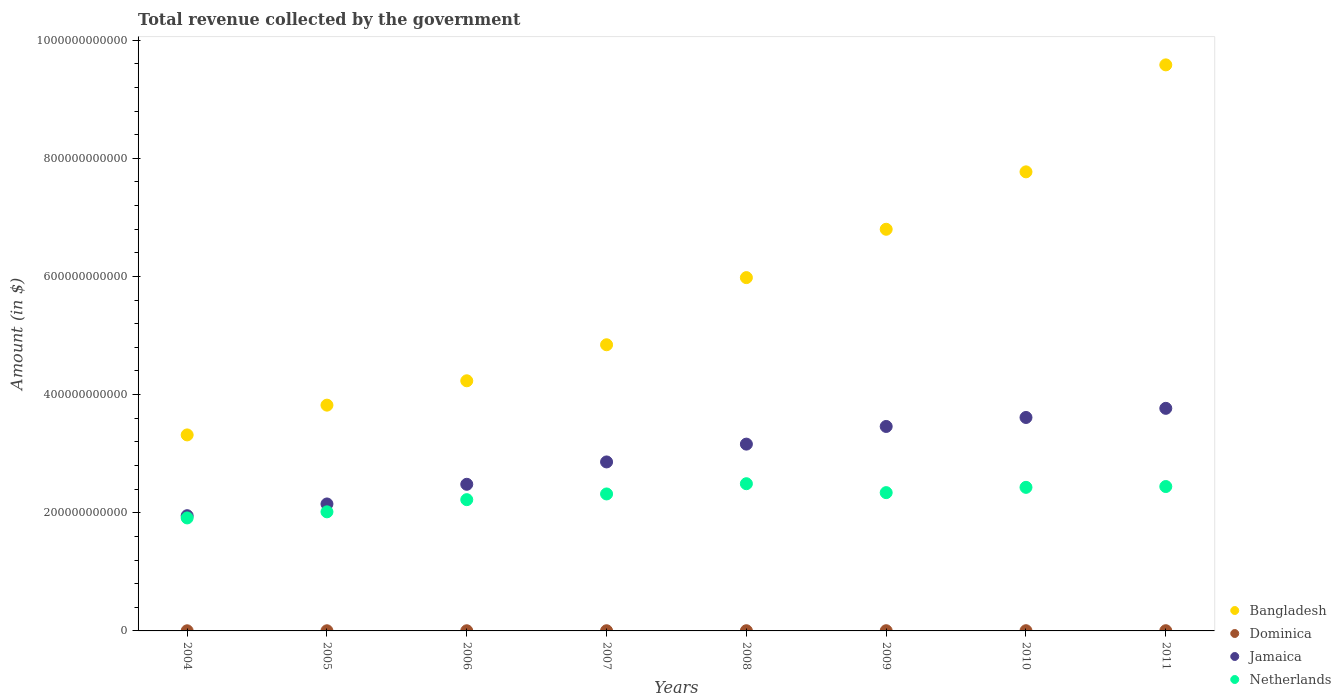How many different coloured dotlines are there?
Ensure brevity in your answer.  4. Is the number of dotlines equal to the number of legend labels?
Your response must be concise. Yes. What is the total revenue collected by the government in Netherlands in 2005?
Provide a succinct answer. 2.02e+11. Across all years, what is the maximum total revenue collected by the government in Bangladesh?
Provide a succinct answer. 9.58e+11. Across all years, what is the minimum total revenue collected by the government in Bangladesh?
Give a very brief answer. 3.32e+11. In which year was the total revenue collected by the government in Dominica maximum?
Make the answer very short. 2011. In which year was the total revenue collected by the government in Netherlands minimum?
Your answer should be very brief. 2004. What is the total total revenue collected by the government in Bangladesh in the graph?
Provide a short and direct response. 4.64e+12. What is the difference between the total revenue collected by the government in Netherlands in 2006 and that in 2008?
Provide a succinct answer. -2.70e+1. What is the difference between the total revenue collected by the government in Dominica in 2006 and the total revenue collected by the government in Netherlands in 2011?
Provide a succinct answer. -2.44e+11. What is the average total revenue collected by the government in Bangladesh per year?
Make the answer very short. 5.79e+11. In the year 2006, what is the difference between the total revenue collected by the government in Bangladesh and total revenue collected by the government in Jamaica?
Give a very brief answer. 1.75e+11. In how many years, is the total revenue collected by the government in Dominica greater than 520000000000 $?
Offer a very short reply. 0. What is the ratio of the total revenue collected by the government in Bangladesh in 2004 to that in 2010?
Your response must be concise. 0.43. What is the difference between the highest and the second highest total revenue collected by the government in Jamaica?
Make the answer very short. 1.55e+1. What is the difference between the highest and the lowest total revenue collected by the government in Netherlands?
Ensure brevity in your answer.  5.79e+1. Is the sum of the total revenue collected by the government in Jamaica in 2007 and 2008 greater than the maximum total revenue collected by the government in Netherlands across all years?
Provide a succinct answer. Yes. Is it the case that in every year, the sum of the total revenue collected by the government in Bangladesh and total revenue collected by the government in Dominica  is greater than the sum of total revenue collected by the government in Jamaica and total revenue collected by the government in Netherlands?
Give a very brief answer. No. Is the total revenue collected by the government in Dominica strictly greater than the total revenue collected by the government in Netherlands over the years?
Your answer should be compact. No. What is the difference between two consecutive major ticks on the Y-axis?
Provide a succinct answer. 2.00e+11. Does the graph contain grids?
Your response must be concise. No. How are the legend labels stacked?
Offer a very short reply. Vertical. What is the title of the graph?
Your answer should be compact. Total revenue collected by the government. Does "Ecuador" appear as one of the legend labels in the graph?
Offer a very short reply. No. What is the label or title of the X-axis?
Keep it short and to the point. Years. What is the label or title of the Y-axis?
Give a very brief answer. Amount (in $). What is the Amount (in $) of Bangladesh in 2004?
Make the answer very short. 3.32e+11. What is the Amount (in $) of Dominica in 2004?
Your response must be concise. 2.34e+08. What is the Amount (in $) in Jamaica in 2004?
Your response must be concise. 1.95e+11. What is the Amount (in $) of Netherlands in 2004?
Keep it short and to the point. 1.91e+11. What is the Amount (in $) of Bangladesh in 2005?
Offer a very short reply. 3.82e+11. What is the Amount (in $) in Dominica in 2005?
Offer a terse response. 2.55e+08. What is the Amount (in $) of Jamaica in 2005?
Ensure brevity in your answer.  2.15e+11. What is the Amount (in $) of Netherlands in 2005?
Provide a short and direct response. 2.02e+11. What is the Amount (in $) in Bangladesh in 2006?
Provide a succinct answer. 4.23e+11. What is the Amount (in $) in Dominica in 2006?
Your answer should be very brief. 2.69e+08. What is the Amount (in $) in Jamaica in 2006?
Provide a short and direct response. 2.48e+11. What is the Amount (in $) of Netherlands in 2006?
Provide a short and direct response. 2.22e+11. What is the Amount (in $) of Bangladesh in 2007?
Give a very brief answer. 4.84e+11. What is the Amount (in $) in Dominica in 2007?
Your answer should be compact. 3.12e+08. What is the Amount (in $) in Jamaica in 2007?
Ensure brevity in your answer.  2.86e+11. What is the Amount (in $) in Netherlands in 2007?
Your answer should be very brief. 2.32e+11. What is the Amount (in $) of Bangladesh in 2008?
Offer a terse response. 5.98e+11. What is the Amount (in $) of Dominica in 2008?
Provide a succinct answer. 3.38e+08. What is the Amount (in $) of Jamaica in 2008?
Keep it short and to the point. 3.16e+11. What is the Amount (in $) of Netherlands in 2008?
Your answer should be compact. 2.49e+11. What is the Amount (in $) in Bangladesh in 2009?
Your response must be concise. 6.80e+11. What is the Amount (in $) of Dominica in 2009?
Provide a succinct answer. 3.50e+08. What is the Amount (in $) in Jamaica in 2009?
Provide a short and direct response. 3.46e+11. What is the Amount (in $) of Netherlands in 2009?
Offer a very short reply. 2.34e+11. What is the Amount (in $) in Bangladesh in 2010?
Offer a very short reply. 7.77e+11. What is the Amount (in $) in Dominica in 2010?
Provide a succinct answer. 3.52e+08. What is the Amount (in $) of Jamaica in 2010?
Your answer should be very brief. 3.61e+11. What is the Amount (in $) in Netherlands in 2010?
Provide a short and direct response. 2.43e+11. What is the Amount (in $) in Bangladesh in 2011?
Your answer should be compact. 9.58e+11. What is the Amount (in $) in Dominica in 2011?
Offer a terse response. 3.57e+08. What is the Amount (in $) in Jamaica in 2011?
Your response must be concise. 3.77e+11. What is the Amount (in $) in Netherlands in 2011?
Provide a succinct answer. 2.44e+11. Across all years, what is the maximum Amount (in $) in Bangladesh?
Provide a succinct answer. 9.58e+11. Across all years, what is the maximum Amount (in $) in Dominica?
Your response must be concise. 3.57e+08. Across all years, what is the maximum Amount (in $) in Jamaica?
Your answer should be compact. 3.77e+11. Across all years, what is the maximum Amount (in $) in Netherlands?
Give a very brief answer. 2.49e+11. Across all years, what is the minimum Amount (in $) in Bangladesh?
Provide a short and direct response. 3.32e+11. Across all years, what is the minimum Amount (in $) of Dominica?
Offer a very short reply. 2.34e+08. Across all years, what is the minimum Amount (in $) of Jamaica?
Offer a very short reply. 1.95e+11. Across all years, what is the minimum Amount (in $) of Netherlands?
Offer a very short reply. 1.91e+11. What is the total Amount (in $) in Bangladesh in the graph?
Your answer should be compact. 4.64e+12. What is the total Amount (in $) in Dominica in the graph?
Your response must be concise. 2.47e+09. What is the total Amount (in $) of Jamaica in the graph?
Your answer should be compact. 2.34e+12. What is the total Amount (in $) of Netherlands in the graph?
Make the answer very short. 1.82e+12. What is the difference between the Amount (in $) of Bangladesh in 2004 and that in 2005?
Make the answer very short. -5.04e+1. What is the difference between the Amount (in $) of Dominica in 2004 and that in 2005?
Your answer should be very brief. -2.06e+07. What is the difference between the Amount (in $) of Jamaica in 2004 and that in 2005?
Make the answer very short. -1.99e+1. What is the difference between the Amount (in $) in Netherlands in 2004 and that in 2005?
Your answer should be compact. -1.03e+1. What is the difference between the Amount (in $) in Bangladesh in 2004 and that in 2006?
Your answer should be compact. -9.16e+1. What is the difference between the Amount (in $) in Dominica in 2004 and that in 2006?
Provide a short and direct response. -3.46e+07. What is the difference between the Amount (in $) in Jamaica in 2004 and that in 2006?
Your response must be concise. -5.32e+1. What is the difference between the Amount (in $) of Netherlands in 2004 and that in 2006?
Give a very brief answer. -3.09e+1. What is the difference between the Amount (in $) of Bangladesh in 2004 and that in 2007?
Keep it short and to the point. -1.53e+11. What is the difference between the Amount (in $) of Dominica in 2004 and that in 2007?
Give a very brief answer. -7.77e+07. What is the difference between the Amount (in $) in Jamaica in 2004 and that in 2007?
Give a very brief answer. -9.10e+1. What is the difference between the Amount (in $) in Netherlands in 2004 and that in 2007?
Your response must be concise. -4.06e+1. What is the difference between the Amount (in $) in Bangladesh in 2004 and that in 2008?
Offer a terse response. -2.66e+11. What is the difference between the Amount (in $) of Dominica in 2004 and that in 2008?
Your answer should be very brief. -1.03e+08. What is the difference between the Amount (in $) of Jamaica in 2004 and that in 2008?
Make the answer very short. -1.21e+11. What is the difference between the Amount (in $) in Netherlands in 2004 and that in 2008?
Make the answer very short. -5.79e+1. What is the difference between the Amount (in $) in Bangladesh in 2004 and that in 2009?
Your answer should be compact. -3.48e+11. What is the difference between the Amount (in $) in Dominica in 2004 and that in 2009?
Offer a terse response. -1.16e+08. What is the difference between the Amount (in $) of Jamaica in 2004 and that in 2009?
Provide a succinct answer. -1.51e+11. What is the difference between the Amount (in $) in Netherlands in 2004 and that in 2009?
Make the answer very short. -4.28e+1. What is the difference between the Amount (in $) in Bangladesh in 2004 and that in 2010?
Make the answer very short. -4.45e+11. What is the difference between the Amount (in $) of Dominica in 2004 and that in 2010?
Ensure brevity in your answer.  -1.17e+08. What is the difference between the Amount (in $) of Jamaica in 2004 and that in 2010?
Make the answer very short. -1.66e+11. What is the difference between the Amount (in $) in Netherlands in 2004 and that in 2010?
Provide a short and direct response. -5.18e+1. What is the difference between the Amount (in $) of Bangladesh in 2004 and that in 2011?
Provide a short and direct response. -6.26e+11. What is the difference between the Amount (in $) of Dominica in 2004 and that in 2011?
Offer a terse response. -1.23e+08. What is the difference between the Amount (in $) of Jamaica in 2004 and that in 2011?
Provide a succinct answer. -1.82e+11. What is the difference between the Amount (in $) of Netherlands in 2004 and that in 2011?
Provide a short and direct response. -5.31e+1. What is the difference between the Amount (in $) of Bangladesh in 2005 and that in 2006?
Keep it short and to the point. -4.12e+1. What is the difference between the Amount (in $) in Dominica in 2005 and that in 2006?
Make the answer very short. -1.40e+07. What is the difference between the Amount (in $) of Jamaica in 2005 and that in 2006?
Keep it short and to the point. -3.33e+1. What is the difference between the Amount (in $) in Netherlands in 2005 and that in 2006?
Your answer should be compact. -2.06e+1. What is the difference between the Amount (in $) of Bangladesh in 2005 and that in 2007?
Provide a short and direct response. -1.02e+11. What is the difference between the Amount (in $) in Dominica in 2005 and that in 2007?
Ensure brevity in your answer.  -5.71e+07. What is the difference between the Amount (in $) of Jamaica in 2005 and that in 2007?
Provide a succinct answer. -7.11e+1. What is the difference between the Amount (in $) in Netherlands in 2005 and that in 2007?
Make the answer very short. -3.03e+1. What is the difference between the Amount (in $) in Bangladesh in 2005 and that in 2008?
Your response must be concise. -2.16e+11. What is the difference between the Amount (in $) of Dominica in 2005 and that in 2008?
Make the answer very short. -8.27e+07. What is the difference between the Amount (in $) in Jamaica in 2005 and that in 2008?
Give a very brief answer. -1.01e+11. What is the difference between the Amount (in $) of Netherlands in 2005 and that in 2008?
Your answer should be compact. -4.76e+1. What is the difference between the Amount (in $) of Bangladesh in 2005 and that in 2009?
Make the answer very short. -2.98e+11. What is the difference between the Amount (in $) in Dominica in 2005 and that in 2009?
Keep it short and to the point. -9.50e+07. What is the difference between the Amount (in $) of Jamaica in 2005 and that in 2009?
Your answer should be compact. -1.31e+11. What is the difference between the Amount (in $) in Netherlands in 2005 and that in 2009?
Give a very brief answer. -3.25e+1. What is the difference between the Amount (in $) in Bangladesh in 2005 and that in 2010?
Offer a terse response. -3.95e+11. What is the difference between the Amount (in $) in Dominica in 2005 and that in 2010?
Provide a short and direct response. -9.68e+07. What is the difference between the Amount (in $) in Jamaica in 2005 and that in 2010?
Make the answer very short. -1.46e+11. What is the difference between the Amount (in $) of Netherlands in 2005 and that in 2010?
Offer a very short reply. -4.14e+1. What is the difference between the Amount (in $) of Bangladesh in 2005 and that in 2011?
Your answer should be very brief. -5.76e+11. What is the difference between the Amount (in $) in Dominica in 2005 and that in 2011?
Offer a very short reply. -1.02e+08. What is the difference between the Amount (in $) of Jamaica in 2005 and that in 2011?
Provide a short and direct response. -1.62e+11. What is the difference between the Amount (in $) in Netherlands in 2005 and that in 2011?
Your answer should be compact. -4.28e+1. What is the difference between the Amount (in $) of Bangladesh in 2006 and that in 2007?
Give a very brief answer. -6.10e+1. What is the difference between the Amount (in $) in Dominica in 2006 and that in 2007?
Keep it short and to the point. -4.31e+07. What is the difference between the Amount (in $) in Jamaica in 2006 and that in 2007?
Offer a terse response. -3.78e+1. What is the difference between the Amount (in $) in Netherlands in 2006 and that in 2007?
Provide a short and direct response. -9.66e+09. What is the difference between the Amount (in $) of Bangladesh in 2006 and that in 2008?
Ensure brevity in your answer.  -1.75e+11. What is the difference between the Amount (in $) in Dominica in 2006 and that in 2008?
Offer a very short reply. -6.87e+07. What is the difference between the Amount (in $) of Jamaica in 2006 and that in 2008?
Keep it short and to the point. -6.80e+1. What is the difference between the Amount (in $) in Netherlands in 2006 and that in 2008?
Your answer should be compact. -2.70e+1. What is the difference between the Amount (in $) in Bangladesh in 2006 and that in 2009?
Keep it short and to the point. -2.56e+11. What is the difference between the Amount (in $) in Dominica in 2006 and that in 2009?
Make the answer very short. -8.10e+07. What is the difference between the Amount (in $) of Jamaica in 2006 and that in 2009?
Your response must be concise. -9.79e+1. What is the difference between the Amount (in $) of Netherlands in 2006 and that in 2009?
Your answer should be very brief. -1.19e+1. What is the difference between the Amount (in $) of Bangladesh in 2006 and that in 2010?
Provide a short and direct response. -3.54e+11. What is the difference between the Amount (in $) in Dominica in 2006 and that in 2010?
Offer a terse response. -8.28e+07. What is the difference between the Amount (in $) in Jamaica in 2006 and that in 2010?
Provide a short and direct response. -1.13e+11. What is the difference between the Amount (in $) in Netherlands in 2006 and that in 2010?
Provide a short and direct response. -2.08e+1. What is the difference between the Amount (in $) of Bangladesh in 2006 and that in 2011?
Make the answer very short. -5.35e+11. What is the difference between the Amount (in $) in Dominica in 2006 and that in 2011?
Your answer should be very brief. -8.83e+07. What is the difference between the Amount (in $) of Jamaica in 2006 and that in 2011?
Your answer should be very brief. -1.29e+11. What is the difference between the Amount (in $) of Netherlands in 2006 and that in 2011?
Provide a succinct answer. -2.22e+1. What is the difference between the Amount (in $) in Bangladesh in 2007 and that in 2008?
Offer a terse response. -1.14e+11. What is the difference between the Amount (in $) of Dominica in 2007 and that in 2008?
Keep it short and to the point. -2.56e+07. What is the difference between the Amount (in $) of Jamaica in 2007 and that in 2008?
Make the answer very short. -3.02e+1. What is the difference between the Amount (in $) in Netherlands in 2007 and that in 2008?
Keep it short and to the point. -1.73e+1. What is the difference between the Amount (in $) of Bangladesh in 2007 and that in 2009?
Offer a very short reply. -1.95e+11. What is the difference between the Amount (in $) in Dominica in 2007 and that in 2009?
Ensure brevity in your answer.  -3.79e+07. What is the difference between the Amount (in $) of Jamaica in 2007 and that in 2009?
Give a very brief answer. -6.01e+1. What is the difference between the Amount (in $) in Netherlands in 2007 and that in 2009?
Offer a very short reply. -2.24e+09. What is the difference between the Amount (in $) of Bangladesh in 2007 and that in 2010?
Provide a short and direct response. -2.93e+11. What is the difference between the Amount (in $) in Dominica in 2007 and that in 2010?
Ensure brevity in your answer.  -3.97e+07. What is the difference between the Amount (in $) in Jamaica in 2007 and that in 2010?
Your answer should be compact. -7.53e+1. What is the difference between the Amount (in $) of Netherlands in 2007 and that in 2010?
Make the answer very short. -1.12e+1. What is the difference between the Amount (in $) in Bangladesh in 2007 and that in 2011?
Keep it short and to the point. -4.74e+11. What is the difference between the Amount (in $) of Dominica in 2007 and that in 2011?
Keep it short and to the point. -4.52e+07. What is the difference between the Amount (in $) of Jamaica in 2007 and that in 2011?
Keep it short and to the point. -9.07e+1. What is the difference between the Amount (in $) of Netherlands in 2007 and that in 2011?
Give a very brief answer. -1.26e+1. What is the difference between the Amount (in $) of Bangladesh in 2008 and that in 2009?
Offer a terse response. -8.18e+1. What is the difference between the Amount (in $) in Dominica in 2008 and that in 2009?
Keep it short and to the point. -1.23e+07. What is the difference between the Amount (in $) in Jamaica in 2008 and that in 2009?
Your response must be concise. -2.99e+1. What is the difference between the Amount (in $) of Netherlands in 2008 and that in 2009?
Provide a succinct answer. 1.51e+1. What is the difference between the Amount (in $) in Bangladesh in 2008 and that in 2010?
Provide a succinct answer. -1.79e+11. What is the difference between the Amount (in $) of Dominica in 2008 and that in 2010?
Provide a succinct answer. -1.41e+07. What is the difference between the Amount (in $) in Jamaica in 2008 and that in 2010?
Ensure brevity in your answer.  -4.51e+1. What is the difference between the Amount (in $) of Netherlands in 2008 and that in 2010?
Offer a very short reply. 6.16e+09. What is the difference between the Amount (in $) of Bangladesh in 2008 and that in 2011?
Provide a short and direct response. -3.60e+11. What is the difference between the Amount (in $) in Dominica in 2008 and that in 2011?
Offer a very short reply. -1.96e+07. What is the difference between the Amount (in $) in Jamaica in 2008 and that in 2011?
Your response must be concise. -6.06e+1. What is the difference between the Amount (in $) in Netherlands in 2008 and that in 2011?
Your answer should be compact. 4.76e+09. What is the difference between the Amount (in $) in Bangladesh in 2009 and that in 2010?
Your answer should be very brief. -9.72e+1. What is the difference between the Amount (in $) in Dominica in 2009 and that in 2010?
Your answer should be very brief. -1.80e+06. What is the difference between the Amount (in $) of Jamaica in 2009 and that in 2010?
Keep it short and to the point. -1.52e+1. What is the difference between the Amount (in $) of Netherlands in 2009 and that in 2010?
Your answer should be very brief. -8.94e+09. What is the difference between the Amount (in $) of Bangladesh in 2009 and that in 2011?
Offer a terse response. -2.78e+11. What is the difference between the Amount (in $) in Dominica in 2009 and that in 2011?
Offer a very short reply. -7.30e+06. What is the difference between the Amount (in $) of Jamaica in 2009 and that in 2011?
Your answer should be very brief. -3.07e+1. What is the difference between the Amount (in $) of Netherlands in 2009 and that in 2011?
Give a very brief answer. -1.03e+1. What is the difference between the Amount (in $) of Bangladesh in 2010 and that in 2011?
Make the answer very short. -1.81e+11. What is the difference between the Amount (in $) in Dominica in 2010 and that in 2011?
Your answer should be compact. -5.50e+06. What is the difference between the Amount (in $) in Jamaica in 2010 and that in 2011?
Make the answer very short. -1.55e+1. What is the difference between the Amount (in $) of Netherlands in 2010 and that in 2011?
Provide a short and direct response. -1.39e+09. What is the difference between the Amount (in $) of Bangladesh in 2004 and the Amount (in $) of Dominica in 2005?
Your answer should be compact. 3.32e+11. What is the difference between the Amount (in $) in Bangladesh in 2004 and the Amount (in $) in Jamaica in 2005?
Your response must be concise. 1.17e+11. What is the difference between the Amount (in $) in Bangladesh in 2004 and the Amount (in $) in Netherlands in 2005?
Offer a very short reply. 1.30e+11. What is the difference between the Amount (in $) of Dominica in 2004 and the Amount (in $) of Jamaica in 2005?
Give a very brief answer. -2.15e+11. What is the difference between the Amount (in $) in Dominica in 2004 and the Amount (in $) in Netherlands in 2005?
Provide a short and direct response. -2.01e+11. What is the difference between the Amount (in $) in Jamaica in 2004 and the Amount (in $) in Netherlands in 2005?
Your response must be concise. -6.53e+09. What is the difference between the Amount (in $) of Bangladesh in 2004 and the Amount (in $) of Dominica in 2006?
Keep it short and to the point. 3.32e+11. What is the difference between the Amount (in $) in Bangladesh in 2004 and the Amount (in $) in Jamaica in 2006?
Your answer should be compact. 8.36e+1. What is the difference between the Amount (in $) of Bangladesh in 2004 and the Amount (in $) of Netherlands in 2006?
Keep it short and to the point. 1.10e+11. What is the difference between the Amount (in $) of Dominica in 2004 and the Amount (in $) of Jamaica in 2006?
Your answer should be compact. -2.48e+11. What is the difference between the Amount (in $) in Dominica in 2004 and the Amount (in $) in Netherlands in 2006?
Offer a very short reply. -2.22e+11. What is the difference between the Amount (in $) of Jamaica in 2004 and the Amount (in $) of Netherlands in 2006?
Offer a very short reply. -2.71e+1. What is the difference between the Amount (in $) in Bangladesh in 2004 and the Amount (in $) in Dominica in 2007?
Provide a succinct answer. 3.31e+11. What is the difference between the Amount (in $) in Bangladesh in 2004 and the Amount (in $) in Jamaica in 2007?
Ensure brevity in your answer.  4.58e+1. What is the difference between the Amount (in $) of Bangladesh in 2004 and the Amount (in $) of Netherlands in 2007?
Your response must be concise. 9.99e+1. What is the difference between the Amount (in $) of Dominica in 2004 and the Amount (in $) of Jamaica in 2007?
Ensure brevity in your answer.  -2.86e+11. What is the difference between the Amount (in $) in Dominica in 2004 and the Amount (in $) in Netherlands in 2007?
Ensure brevity in your answer.  -2.32e+11. What is the difference between the Amount (in $) of Jamaica in 2004 and the Amount (in $) of Netherlands in 2007?
Ensure brevity in your answer.  -3.68e+1. What is the difference between the Amount (in $) in Bangladesh in 2004 and the Amount (in $) in Dominica in 2008?
Your answer should be compact. 3.31e+11. What is the difference between the Amount (in $) of Bangladesh in 2004 and the Amount (in $) of Jamaica in 2008?
Make the answer very short. 1.56e+1. What is the difference between the Amount (in $) in Bangladesh in 2004 and the Amount (in $) in Netherlands in 2008?
Provide a succinct answer. 8.26e+1. What is the difference between the Amount (in $) in Dominica in 2004 and the Amount (in $) in Jamaica in 2008?
Keep it short and to the point. -3.16e+11. What is the difference between the Amount (in $) in Dominica in 2004 and the Amount (in $) in Netherlands in 2008?
Your answer should be very brief. -2.49e+11. What is the difference between the Amount (in $) in Jamaica in 2004 and the Amount (in $) in Netherlands in 2008?
Give a very brief answer. -5.41e+1. What is the difference between the Amount (in $) of Bangladesh in 2004 and the Amount (in $) of Dominica in 2009?
Your answer should be very brief. 3.31e+11. What is the difference between the Amount (in $) of Bangladesh in 2004 and the Amount (in $) of Jamaica in 2009?
Provide a short and direct response. -1.43e+1. What is the difference between the Amount (in $) of Bangladesh in 2004 and the Amount (in $) of Netherlands in 2009?
Offer a very short reply. 9.77e+1. What is the difference between the Amount (in $) of Dominica in 2004 and the Amount (in $) of Jamaica in 2009?
Give a very brief answer. -3.46e+11. What is the difference between the Amount (in $) of Dominica in 2004 and the Amount (in $) of Netherlands in 2009?
Your answer should be compact. -2.34e+11. What is the difference between the Amount (in $) of Jamaica in 2004 and the Amount (in $) of Netherlands in 2009?
Ensure brevity in your answer.  -3.90e+1. What is the difference between the Amount (in $) in Bangladesh in 2004 and the Amount (in $) in Dominica in 2010?
Provide a short and direct response. 3.31e+11. What is the difference between the Amount (in $) in Bangladesh in 2004 and the Amount (in $) in Jamaica in 2010?
Offer a very short reply. -2.95e+1. What is the difference between the Amount (in $) of Bangladesh in 2004 and the Amount (in $) of Netherlands in 2010?
Give a very brief answer. 8.88e+1. What is the difference between the Amount (in $) in Dominica in 2004 and the Amount (in $) in Jamaica in 2010?
Provide a succinct answer. -3.61e+11. What is the difference between the Amount (in $) in Dominica in 2004 and the Amount (in $) in Netherlands in 2010?
Provide a succinct answer. -2.43e+11. What is the difference between the Amount (in $) of Jamaica in 2004 and the Amount (in $) of Netherlands in 2010?
Your response must be concise. -4.80e+1. What is the difference between the Amount (in $) in Bangladesh in 2004 and the Amount (in $) in Dominica in 2011?
Keep it short and to the point. 3.31e+11. What is the difference between the Amount (in $) in Bangladesh in 2004 and the Amount (in $) in Jamaica in 2011?
Offer a terse response. -4.50e+1. What is the difference between the Amount (in $) of Bangladesh in 2004 and the Amount (in $) of Netherlands in 2011?
Offer a terse response. 8.74e+1. What is the difference between the Amount (in $) in Dominica in 2004 and the Amount (in $) in Jamaica in 2011?
Your answer should be compact. -3.77e+11. What is the difference between the Amount (in $) in Dominica in 2004 and the Amount (in $) in Netherlands in 2011?
Make the answer very short. -2.44e+11. What is the difference between the Amount (in $) of Jamaica in 2004 and the Amount (in $) of Netherlands in 2011?
Provide a short and direct response. -4.94e+1. What is the difference between the Amount (in $) of Bangladesh in 2005 and the Amount (in $) of Dominica in 2006?
Make the answer very short. 3.82e+11. What is the difference between the Amount (in $) in Bangladesh in 2005 and the Amount (in $) in Jamaica in 2006?
Offer a very short reply. 1.34e+11. What is the difference between the Amount (in $) of Bangladesh in 2005 and the Amount (in $) of Netherlands in 2006?
Offer a very short reply. 1.60e+11. What is the difference between the Amount (in $) of Dominica in 2005 and the Amount (in $) of Jamaica in 2006?
Give a very brief answer. -2.48e+11. What is the difference between the Amount (in $) of Dominica in 2005 and the Amount (in $) of Netherlands in 2006?
Your response must be concise. -2.22e+11. What is the difference between the Amount (in $) in Jamaica in 2005 and the Amount (in $) in Netherlands in 2006?
Ensure brevity in your answer.  -7.29e+09. What is the difference between the Amount (in $) of Bangladesh in 2005 and the Amount (in $) of Dominica in 2007?
Offer a very short reply. 3.82e+11. What is the difference between the Amount (in $) in Bangladesh in 2005 and the Amount (in $) in Jamaica in 2007?
Your response must be concise. 9.61e+1. What is the difference between the Amount (in $) of Bangladesh in 2005 and the Amount (in $) of Netherlands in 2007?
Your response must be concise. 1.50e+11. What is the difference between the Amount (in $) in Dominica in 2005 and the Amount (in $) in Jamaica in 2007?
Keep it short and to the point. -2.86e+11. What is the difference between the Amount (in $) in Dominica in 2005 and the Amount (in $) in Netherlands in 2007?
Your response must be concise. -2.32e+11. What is the difference between the Amount (in $) in Jamaica in 2005 and the Amount (in $) in Netherlands in 2007?
Your response must be concise. -1.69e+1. What is the difference between the Amount (in $) in Bangladesh in 2005 and the Amount (in $) in Dominica in 2008?
Keep it short and to the point. 3.82e+11. What is the difference between the Amount (in $) in Bangladesh in 2005 and the Amount (in $) in Jamaica in 2008?
Offer a very short reply. 6.60e+1. What is the difference between the Amount (in $) in Bangladesh in 2005 and the Amount (in $) in Netherlands in 2008?
Ensure brevity in your answer.  1.33e+11. What is the difference between the Amount (in $) of Dominica in 2005 and the Amount (in $) of Jamaica in 2008?
Make the answer very short. -3.16e+11. What is the difference between the Amount (in $) in Dominica in 2005 and the Amount (in $) in Netherlands in 2008?
Your answer should be compact. -2.49e+11. What is the difference between the Amount (in $) of Jamaica in 2005 and the Amount (in $) of Netherlands in 2008?
Provide a short and direct response. -3.43e+1. What is the difference between the Amount (in $) of Bangladesh in 2005 and the Amount (in $) of Dominica in 2009?
Ensure brevity in your answer.  3.82e+11. What is the difference between the Amount (in $) in Bangladesh in 2005 and the Amount (in $) in Jamaica in 2009?
Give a very brief answer. 3.61e+1. What is the difference between the Amount (in $) in Bangladesh in 2005 and the Amount (in $) in Netherlands in 2009?
Your answer should be compact. 1.48e+11. What is the difference between the Amount (in $) in Dominica in 2005 and the Amount (in $) in Jamaica in 2009?
Offer a terse response. -3.46e+11. What is the difference between the Amount (in $) of Dominica in 2005 and the Amount (in $) of Netherlands in 2009?
Make the answer very short. -2.34e+11. What is the difference between the Amount (in $) in Jamaica in 2005 and the Amount (in $) in Netherlands in 2009?
Ensure brevity in your answer.  -1.92e+1. What is the difference between the Amount (in $) in Bangladesh in 2005 and the Amount (in $) in Dominica in 2010?
Offer a very short reply. 3.82e+11. What is the difference between the Amount (in $) in Bangladesh in 2005 and the Amount (in $) in Jamaica in 2010?
Your answer should be very brief. 2.09e+1. What is the difference between the Amount (in $) of Bangladesh in 2005 and the Amount (in $) of Netherlands in 2010?
Your response must be concise. 1.39e+11. What is the difference between the Amount (in $) of Dominica in 2005 and the Amount (in $) of Jamaica in 2010?
Offer a very short reply. -3.61e+11. What is the difference between the Amount (in $) in Dominica in 2005 and the Amount (in $) in Netherlands in 2010?
Keep it short and to the point. -2.43e+11. What is the difference between the Amount (in $) of Jamaica in 2005 and the Amount (in $) of Netherlands in 2010?
Offer a very short reply. -2.81e+1. What is the difference between the Amount (in $) in Bangladesh in 2005 and the Amount (in $) in Dominica in 2011?
Give a very brief answer. 3.82e+11. What is the difference between the Amount (in $) in Bangladesh in 2005 and the Amount (in $) in Jamaica in 2011?
Your response must be concise. 5.41e+09. What is the difference between the Amount (in $) of Bangladesh in 2005 and the Amount (in $) of Netherlands in 2011?
Your response must be concise. 1.38e+11. What is the difference between the Amount (in $) in Dominica in 2005 and the Amount (in $) in Jamaica in 2011?
Offer a very short reply. -3.77e+11. What is the difference between the Amount (in $) in Dominica in 2005 and the Amount (in $) in Netherlands in 2011?
Offer a very short reply. -2.44e+11. What is the difference between the Amount (in $) of Jamaica in 2005 and the Amount (in $) of Netherlands in 2011?
Your response must be concise. -2.95e+1. What is the difference between the Amount (in $) in Bangladesh in 2006 and the Amount (in $) in Dominica in 2007?
Provide a succinct answer. 4.23e+11. What is the difference between the Amount (in $) of Bangladesh in 2006 and the Amount (in $) of Jamaica in 2007?
Give a very brief answer. 1.37e+11. What is the difference between the Amount (in $) in Bangladesh in 2006 and the Amount (in $) in Netherlands in 2007?
Your response must be concise. 1.92e+11. What is the difference between the Amount (in $) of Dominica in 2006 and the Amount (in $) of Jamaica in 2007?
Your answer should be very brief. -2.86e+11. What is the difference between the Amount (in $) of Dominica in 2006 and the Amount (in $) of Netherlands in 2007?
Provide a succinct answer. -2.32e+11. What is the difference between the Amount (in $) of Jamaica in 2006 and the Amount (in $) of Netherlands in 2007?
Your answer should be very brief. 1.63e+1. What is the difference between the Amount (in $) of Bangladesh in 2006 and the Amount (in $) of Dominica in 2008?
Your response must be concise. 4.23e+11. What is the difference between the Amount (in $) in Bangladesh in 2006 and the Amount (in $) in Jamaica in 2008?
Provide a succinct answer. 1.07e+11. What is the difference between the Amount (in $) in Bangladesh in 2006 and the Amount (in $) in Netherlands in 2008?
Provide a short and direct response. 1.74e+11. What is the difference between the Amount (in $) in Dominica in 2006 and the Amount (in $) in Jamaica in 2008?
Your answer should be compact. -3.16e+11. What is the difference between the Amount (in $) of Dominica in 2006 and the Amount (in $) of Netherlands in 2008?
Ensure brevity in your answer.  -2.49e+11. What is the difference between the Amount (in $) in Jamaica in 2006 and the Amount (in $) in Netherlands in 2008?
Your answer should be compact. -9.79e+08. What is the difference between the Amount (in $) in Bangladesh in 2006 and the Amount (in $) in Dominica in 2009?
Your answer should be very brief. 4.23e+11. What is the difference between the Amount (in $) in Bangladesh in 2006 and the Amount (in $) in Jamaica in 2009?
Provide a short and direct response. 7.73e+1. What is the difference between the Amount (in $) in Bangladesh in 2006 and the Amount (in $) in Netherlands in 2009?
Keep it short and to the point. 1.89e+11. What is the difference between the Amount (in $) of Dominica in 2006 and the Amount (in $) of Jamaica in 2009?
Your answer should be compact. -3.46e+11. What is the difference between the Amount (in $) of Dominica in 2006 and the Amount (in $) of Netherlands in 2009?
Provide a succinct answer. -2.34e+11. What is the difference between the Amount (in $) of Jamaica in 2006 and the Amount (in $) of Netherlands in 2009?
Ensure brevity in your answer.  1.41e+1. What is the difference between the Amount (in $) in Bangladesh in 2006 and the Amount (in $) in Dominica in 2010?
Make the answer very short. 4.23e+11. What is the difference between the Amount (in $) in Bangladesh in 2006 and the Amount (in $) in Jamaica in 2010?
Offer a very short reply. 6.21e+1. What is the difference between the Amount (in $) of Bangladesh in 2006 and the Amount (in $) of Netherlands in 2010?
Your response must be concise. 1.80e+11. What is the difference between the Amount (in $) in Dominica in 2006 and the Amount (in $) in Jamaica in 2010?
Give a very brief answer. -3.61e+11. What is the difference between the Amount (in $) of Dominica in 2006 and the Amount (in $) of Netherlands in 2010?
Provide a succinct answer. -2.43e+11. What is the difference between the Amount (in $) in Jamaica in 2006 and the Amount (in $) in Netherlands in 2010?
Your answer should be very brief. 5.18e+09. What is the difference between the Amount (in $) in Bangladesh in 2006 and the Amount (in $) in Dominica in 2011?
Give a very brief answer. 4.23e+11. What is the difference between the Amount (in $) of Bangladesh in 2006 and the Amount (in $) of Jamaica in 2011?
Make the answer very short. 4.66e+1. What is the difference between the Amount (in $) in Bangladesh in 2006 and the Amount (in $) in Netherlands in 2011?
Offer a terse response. 1.79e+11. What is the difference between the Amount (in $) in Dominica in 2006 and the Amount (in $) in Jamaica in 2011?
Provide a succinct answer. -3.77e+11. What is the difference between the Amount (in $) in Dominica in 2006 and the Amount (in $) in Netherlands in 2011?
Keep it short and to the point. -2.44e+11. What is the difference between the Amount (in $) in Jamaica in 2006 and the Amount (in $) in Netherlands in 2011?
Offer a very short reply. 3.79e+09. What is the difference between the Amount (in $) of Bangladesh in 2007 and the Amount (in $) of Dominica in 2008?
Provide a succinct answer. 4.84e+11. What is the difference between the Amount (in $) in Bangladesh in 2007 and the Amount (in $) in Jamaica in 2008?
Offer a terse response. 1.68e+11. What is the difference between the Amount (in $) of Bangladesh in 2007 and the Amount (in $) of Netherlands in 2008?
Your response must be concise. 2.35e+11. What is the difference between the Amount (in $) in Dominica in 2007 and the Amount (in $) in Jamaica in 2008?
Offer a terse response. -3.16e+11. What is the difference between the Amount (in $) in Dominica in 2007 and the Amount (in $) in Netherlands in 2008?
Offer a terse response. -2.49e+11. What is the difference between the Amount (in $) in Jamaica in 2007 and the Amount (in $) in Netherlands in 2008?
Your answer should be compact. 3.69e+1. What is the difference between the Amount (in $) of Bangladesh in 2007 and the Amount (in $) of Dominica in 2009?
Offer a terse response. 4.84e+11. What is the difference between the Amount (in $) in Bangladesh in 2007 and the Amount (in $) in Jamaica in 2009?
Your answer should be very brief. 1.38e+11. What is the difference between the Amount (in $) of Bangladesh in 2007 and the Amount (in $) of Netherlands in 2009?
Keep it short and to the point. 2.50e+11. What is the difference between the Amount (in $) of Dominica in 2007 and the Amount (in $) of Jamaica in 2009?
Your answer should be very brief. -3.46e+11. What is the difference between the Amount (in $) in Dominica in 2007 and the Amount (in $) in Netherlands in 2009?
Keep it short and to the point. -2.34e+11. What is the difference between the Amount (in $) of Jamaica in 2007 and the Amount (in $) of Netherlands in 2009?
Your response must be concise. 5.20e+1. What is the difference between the Amount (in $) in Bangladesh in 2007 and the Amount (in $) in Dominica in 2010?
Provide a succinct answer. 4.84e+11. What is the difference between the Amount (in $) of Bangladesh in 2007 and the Amount (in $) of Jamaica in 2010?
Your response must be concise. 1.23e+11. What is the difference between the Amount (in $) in Bangladesh in 2007 and the Amount (in $) in Netherlands in 2010?
Keep it short and to the point. 2.41e+11. What is the difference between the Amount (in $) of Dominica in 2007 and the Amount (in $) of Jamaica in 2010?
Give a very brief answer. -3.61e+11. What is the difference between the Amount (in $) of Dominica in 2007 and the Amount (in $) of Netherlands in 2010?
Give a very brief answer. -2.43e+11. What is the difference between the Amount (in $) in Jamaica in 2007 and the Amount (in $) in Netherlands in 2010?
Give a very brief answer. 4.30e+1. What is the difference between the Amount (in $) in Bangladesh in 2007 and the Amount (in $) in Dominica in 2011?
Ensure brevity in your answer.  4.84e+11. What is the difference between the Amount (in $) in Bangladesh in 2007 and the Amount (in $) in Jamaica in 2011?
Your response must be concise. 1.08e+11. What is the difference between the Amount (in $) in Bangladesh in 2007 and the Amount (in $) in Netherlands in 2011?
Ensure brevity in your answer.  2.40e+11. What is the difference between the Amount (in $) of Dominica in 2007 and the Amount (in $) of Jamaica in 2011?
Give a very brief answer. -3.76e+11. What is the difference between the Amount (in $) of Dominica in 2007 and the Amount (in $) of Netherlands in 2011?
Your response must be concise. -2.44e+11. What is the difference between the Amount (in $) of Jamaica in 2007 and the Amount (in $) of Netherlands in 2011?
Provide a short and direct response. 4.16e+1. What is the difference between the Amount (in $) of Bangladesh in 2008 and the Amount (in $) of Dominica in 2009?
Your response must be concise. 5.98e+11. What is the difference between the Amount (in $) of Bangladesh in 2008 and the Amount (in $) of Jamaica in 2009?
Make the answer very short. 2.52e+11. What is the difference between the Amount (in $) of Bangladesh in 2008 and the Amount (in $) of Netherlands in 2009?
Provide a short and direct response. 3.64e+11. What is the difference between the Amount (in $) of Dominica in 2008 and the Amount (in $) of Jamaica in 2009?
Your response must be concise. -3.46e+11. What is the difference between the Amount (in $) of Dominica in 2008 and the Amount (in $) of Netherlands in 2009?
Your answer should be very brief. -2.34e+11. What is the difference between the Amount (in $) of Jamaica in 2008 and the Amount (in $) of Netherlands in 2009?
Give a very brief answer. 8.21e+1. What is the difference between the Amount (in $) in Bangladesh in 2008 and the Amount (in $) in Dominica in 2010?
Offer a terse response. 5.98e+11. What is the difference between the Amount (in $) in Bangladesh in 2008 and the Amount (in $) in Jamaica in 2010?
Provide a short and direct response. 2.37e+11. What is the difference between the Amount (in $) in Bangladesh in 2008 and the Amount (in $) in Netherlands in 2010?
Your answer should be compact. 3.55e+11. What is the difference between the Amount (in $) of Dominica in 2008 and the Amount (in $) of Jamaica in 2010?
Make the answer very short. -3.61e+11. What is the difference between the Amount (in $) in Dominica in 2008 and the Amount (in $) in Netherlands in 2010?
Give a very brief answer. -2.43e+11. What is the difference between the Amount (in $) in Jamaica in 2008 and the Amount (in $) in Netherlands in 2010?
Make the answer very short. 7.32e+1. What is the difference between the Amount (in $) of Bangladesh in 2008 and the Amount (in $) of Dominica in 2011?
Make the answer very short. 5.98e+11. What is the difference between the Amount (in $) of Bangladesh in 2008 and the Amount (in $) of Jamaica in 2011?
Offer a very short reply. 2.21e+11. What is the difference between the Amount (in $) in Bangladesh in 2008 and the Amount (in $) in Netherlands in 2011?
Give a very brief answer. 3.54e+11. What is the difference between the Amount (in $) of Dominica in 2008 and the Amount (in $) of Jamaica in 2011?
Your response must be concise. -3.76e+11. What is the difference between the Amount (in $) of Dominica in 2008 and the Amount (in $) of Netherlands in 2011?
Make the answer very short. -2.44e+11. What is the difference between the Amount (in $) of Jamaica in 2008 and the Amount (in $) of Netherlands in 2011?
Provide a succinct answer. 7.18e+1. What is the difference between the Amount (in $) in Bangladesh in 2009 and the Amount (in $) in Dominica in 2010?
Give a very brief answer. 6.80e+11. What is the difference between the Amount (in $) in Bangladesh in 2009 and the Amount (in $) in Jamaica in 2010?
Provide a succinct answer. 3.19e+11. What is the difference between the Amount (in $) in Bangladesh in 2009 and the Amount (in $) in Netherlands in 2010?
Make the answer very short. 4.37e+11. What is the difference between the Amount (in $) in Dominica in 2009 and the Amount (in $) in Jamaica in 2010?
Your response must be concise. -3.61e+11. What is the difference between the Amount (in $) of Dominica in 2009 and the Amount (in $) of Netherlands in 2010?
Offer a terse response. -2.43e+11. What is the difference between the Amount (in $) of Jamaica in 2009 and the Amount (in $) of Netherlands in 2010?
Ensure brevity in your answer.  1.03e+11. What is the difference between the Amount (in $) of Bangladesh in 2009 and the Amount (in $) of Dominica in 2011?
Ensure brevity in your answer.  6.80e+11. What is the difference between the Amount (in $) in Bangladesh in 2009 and the Amount (in $) in Jamaica in 2011?
Offer a terse response. 3.03e+11. What is the difference between the Amount (in $) of Bangladesh in 2009 and the Amount (in $) of Netherlands in 2011?
Give a very brief answer. 4.35e+11. What is the difference between the Amount (in $) of Dominica in 2009 and the Amount (in $) of Jamaica in 2011?
Ensure brevity in your answer.  -3.76e+11. What is the difference between the Amount (in $) in Dominica in 2009 and the Amount (in $) in Netherlands in 2011?
Provide a succinct answer. -2.44e+11. What is the difference between the Amount (in $) of Jamaica in 2009 and the Amount (in $) of Netherlands in 2011?
Offer a very short reply. 1.02e+11. What is the difference between the Amount (in $) of Bangladesh in 2010 and the Amount (in $) of Dominica in 2011?
Give a very brief answer. 7.77e+11. What is the difference between the Amount (in $) of Bangladesh in 2010 and the Amount (in $) of Jamaica in 2011?
Make the answer very short. 4.00e+11. What is the difference between the Amount (in $) of Bangladesh in 2010 and the Amount (in $) of Netherlands in 2011?
Keep it short and to the point. 5.33e+11. What is the difference between the Amount (in $) in Dominica in 2010 and the Amount (in $) in Jamaica in 2011?
Offer a terse response. -3.76e+11. What is the difference between the Amount (in $) of Dominica in 2010 and the Amount (in $) of Netherlands in 2011?
Keep it short and to the point. -2.44e+11. What is the difference between the Amount (in $) of Jamaica in 2010 and the Amount (in $) of Netherlands in 2011?
Keep it short and to the point. 1.17e+11. What is the average Amount (in $) in Bangladesh per year?
Offer a very short reply. 5.79e+11. What is the average Amount (in $) of Dominica per year?
Keep it short and to the point. 3.09e+08. What is the average Amount (in $) of Jamaica per year?
Give a very brief answer. 2.93e+11. What is the average Amount (in $) of Netherlands per year?
Keep it short and to the point. 2.27e+11. In the year 2004, what is the difference between the Amount (in $) in Bangladesh and Amount (in $) in Dominica?
Keep it short and to the point. 3.32e+11. In the year 2004, what is the difference between the Amount (in $) in Bangladesh and Amount (in $) in Jamaica?
Your response must be concise. 1.37e+11. In the year 2004, what is the difference between the Amount (in $) in Bangladesh and Amount (in $) in Netherlands?
Offer a terse response. 1.41e+11. In the year 2004, what is the difference between the Amount (in $) of Dominica and Amount (in $) of Jamaica?
Your answer should be very brief. -1.95e+11. In the year 2004, what is the difference between the Amount (in $) in Dominica and Amount (in $) in Netherlands?
Make the answer very short. -1.91e+11. In the year 2004, what is the difference between the Amount (in $) of Jamaica and Amount (in $) of Netherlands?
Offer a terse response. 3.78e+09. In the year 2005, what is the difference between the Amount (in $) in Bangladesh and Amount (in $) in Dominica?
Keep it short and to the point. 3.82e+11. In the year 2005, what is the difference between the Amount (in $) of Bangladesh and Amount (in $) of Jamaica?
Make the answer very short. 1.67e+11. In the year 2005, what is the difference between the Amount (in $) of Bangladesh and Amount (in $) of Netherlands?
Your answer should be compact. 1.81e+11. In the year 2005, what is the difference between the Amount (in $) of Dominica and Amount (in $) of Jamaica?
Offer a terse response. -2.15e+11. In the year 2005, what is the difference between the Amount (in $) in Dominica and Amount (in $) in Netherlands?
Your response must be concise. -2.01e+11. In the year 2005, what is the difference between the Amount (in $) of Jamaica and Amount (in $) of Netherlands?
Give a very brief answer. 1.33e+1. In the year 2006, what is the difference between the Amount (in $) in Bangladesh and Amount (in $) in Dominica?
Provide a short and direct response. 4.23e+11. In the year 2006, what is the difference between the Amount (in $) in Bangladesh and Amount (in $) in Jamaica?
Your answer should be compact. 1.75e+11. In the year 2006, what is the difference between the Amount (in $) in Bangladesh and Amount (in $) in Netherlands?
Provide a short and direct response. 2.01e+11. In the year 2006, what is the difference between the Amount (in $) of Dominica and Amount (in $) of Jamaica?
Ensure brevity in your answer.  -2.48e+11. In the year 2006, what is the difference between the Amount (in $) of Dominica and Amount (in $) of Netherlands?
Provide a short and direct response. -2.22e+11. In the year 2006, what is the difference between the Amount (in $) of Jamaica and Amount (in $) of Netherlands?
Keep it short and to the point. 2.60e+1. In the year 2007, what is the difference between the Amount (in $) in Bangladesh and Amount (in $) in Dominica?
Your answer should be very brief. 4.84e+11. In the year 2007, what is the difference between the Amount (in $) in Bangladesh and Amount (in $) in Jamaica?
Make the answer very short. 1.98e+11. In the year 2007, what is the difference between the Amount (in $) in Bangladesh and Amount (in $) in Netherlands?
Offer a very short reply. 2.53e+11. In the year 2007, what is the difference between the Amount (in $) of Dominica and Amount (in $) of Jamaica?
Your answer should be compact. -2.86e+11. In the year 2007, what is the difference between the Amount (in $) of Dominica and Amount (in $) of Netherlands?
Ensure brevity in your answer.  -2.32e+11. In the year 2007, what is the difference between the Amount (in $) of Jamaica and Amount (in $) of Netherlands?
Provide a succinct answer. 5.42e+1. In the year 2008, what is the difference between the Amount (in $) in Bangladesh and Amount (in $) in Dominica?
Offer a terse response. 5.98e+11. In the year 2008, what is the difference between the Amount (in $) in Bangladesh and Amount (in $) in Jamaica?
Your answer should be very brief. 2.82e+11. In the year 2008, what is the difference between the Amount (in $) of Bangladesh and Amount (in $) of Netherlands?
Keep it short and to the point. 3.49e+11. In the year 2008, what is the difference between the Amount (in $) in Dominica and Amount (in $) in Jamaica?
Provide a short and direct response. -3.16e+11. In the year 2008, what is the difference between the Amount (in $) of Dominica and Amount (in $) of Netherlands?
Make the answer very short. -2.49e+11. In the year 2008, what is the difference between the Amount (in $) in Jamaica and Amount (in $) in Netherlands?
Provide a succinct answer. 6.70e+1. In the year 2009, what is the difference between the Amount (in $) in Bangladesh and Amount (in $) in Dominica?
Your answer should be very brief. 6.80e+11. In the year 2009, what is the difference between the Amount (in $) in Bangladesh and Amount (in $) in Jamaica?
Your answer should be compact. 3.34e+11. In the year 2009, what is the difference between the Amount (in $) in Bangladesh and Amount (in $) in Netherlands?
Provide a succinct answer. 4.46e+11. In the year 2009, what is the difference between the Amount (in $) of Dominica and Amount (in $) of Jamaica?
Offer a very short reply. -3.46e+11. In the year 2009, what is the difference between the Amount (in $) in Dominica and Amount (in $) in Netherlands?
Your answer should be very brief. -2.34e+11. In the year 2009, what is the difference between the Amount (in $) in Jamaica and Amount (in $) in Netherlands?
Keep it short and to the point. 1.12e+11. In the year 2010, what is the difference between the Amount (in $) in Bangladesh and Amount (in $) in Dominica?
Make the answer very short. 7.77e+11. In the year 2010, what is the difference between the Amount (in $) in Bangladesh and Amount (in $) in Jamaica?
Offer a terse response. 4.16e+11. In the year 2010, what is the difference between the Amount (in $) of Bangladesh and Amount (in $) of Netherlands?
Offer a terse response. 5.34e+11. In the year 2010, what is the difference between the Amount (in $) in Dominica and Amount (in $) in Jamaica?
Keep it short and to the point. -3.61e+11. In the year 2010, what is the difference between the Amount (in $) of Dominica and Amount (in $) of Netherlands?
Your answer should be very brief. -2.43e+11. In the year 2010, what is the difference between the Amount (in $) of Jamaica and Amount (in $) of Netherlands?
Your response must be concise. 1.18e+11. In the year 2011, what is the difference between the Amount (in $) in Bangladesh and Amount (in $) in Dominica?
Your answer should be very brief. 9.58e+11. In the year 2011, what is the difference between the Amount (in $) of Bangladesh and Amount (in $) of Jamaica?
Make the answer very short. 5.81e+11. In the year 2011, what is the difference between the Amount (in $) in Bangladesh and Amount (in $) in Netherlands?
Keep it short and to the point. 7.14e+11. In the year 2011, what is the difference between the Amount (in $) in Dominica and Amount (in $) in Jamaica?
Your response must be concise. -3.76e+11. In the year 2011, what is the difference between the Amount (in $) in Dominica and Amount (in $) in Netherlands?
Give a very brief answer. -2.44e+11. In the year 2011, what is the difference between the Amount (in $) of Jamaica and Amount (in $) of Netherlands?
Provide a succinct answer. 1.32e+11. What is the ratio of the Amount (in $) in Bangladesh in 2004 to that in 2005?
Make the answer very short. 0.87. What is the ratio of the Amount (in $) in Dominica in 2004 to that in 2005?
Offer a very short reply. 0.92. What is the ratio of the Amount (in $) in Jamaica in 2004 to that in 2005?
Give a very brief answer. 0.91. What is the ratio of the Amount (in $) in Netherlands in 2004 to that in 2005?
Offer a terse response. 0.95. What is the ratio of the Amount (in $) in Bangladesh in 2004 to that in 2006?
Your response must be concise. 0.78. What is the ratio of the Amount (in $) of Dominica in 2004 to that in 2006?
Keep it short and to the point. 0.87. What is the ratio of the Amount (in $) in Jamaica in 2004 to that in 2006?
Make the answer very short. 0.79. What is the ratio of the Amount (in $) of Netherlands in 2004 to that in 2006?
Your answer should be very brief. 0.86. What is the ratio of the Amount (in $) of Bangladesh in 2004 to that in 2007?
Offer a terse response. 0.69. What is the ratio of the Amount (in $) of Dominica in 2004 to that in 2007?
Your answer should be very brief. 0.75. What is the ratio of the Amount (in $) in Jamaica in 2004 to that in 2007?
Provide a short and direct response. 0.68. What is the ratio of the Amount (in $) of Netherlands in 2004 to that in 2007?
Your answer should be compact. 0.82. What is the ratio of the Amount (in $) in Bangladesh in 2004 to that in 2008?
Offer a very short reply. 0.55. What is the ratio of the Amount (in $) of Dominica in 2004 to that in 2008?
Offer a terse response. 0.69. What is the ratio of the Amount (in $) of Jamaica in 2004 to that in 2008?
Give a very brief answer. 0.62. What is the ratio of the Amount (in $) in Netherlands in 2004 to that in 2008?
Your answer should be compact. 0.77. What is the ratio of the Amount (in $) of Bangladesh in 2004 to that in 2009?
Provide a short and direct response. 0.49. What is the ratio of the Amount (in $) in Dominica in 2004 to that in 2009?
Offer a very short reply. 0.67. What is the ratio of the Amount (in $) in Jamaica in 2004 to that in 2009?
Keep it short and to the point. 0.56. What is the ratio of the Amount (in $) in Netherlands in 2004 to that in 2009?
Offer a terse response. 0.82. What is the ratio of the Amount (in $) in Bangladesh in 2004 to that in 2010?
Keep it short and to the point. 0.43. What is the ratio of the Amount (in $) in Dominica in 2004 to that in 2010?
Provide a short and direct response. 0.67. What is the ratio of the Amount (in $) of Jamaica in 2004 to that in 2010?
Give a very brief answer. 0.54. What is the ratio of the Amount (in $) in Netherlands in 2004 to that in 2010?
Ensure brevity in your answer.  0.79. What is the ratio of the Amount (in $) in Bangladesh in 2004 to that in 2011?
Your response must be concise. 0.35. What is the ratio of the Amount (in $) of Dominica in 2004 to that in 2011?
Provide a short and direct response. 0.66. What is the ratio of the Amount (in $) of Jamaica in 2004 to that in 2011?
Give a very brief answer. 0.52. What is the ratio of the Amount (in $) in Netherlands in 2004 to that in 2011?
Offer a very short reply. 0.78. What is the ratio of the Amount (in $) in Bangladesh in 2005 to that in 2006?
Your answer should be compact. 0.9. What is the ratio of the Amount (in $) in Dominica in 2005 to that in 2006?
Your answer should be compact. 0.95. What is the ratio of the Amount (in $) in Jamaica in 2005 to that in 2006?
Your answer should be very brief. 0.87. What is the ratio of the Amount (in $) in Netherlands in 2005 to that in 2006?
Make the answer very short. 0.91. What is the ratio of the Amount (in $) of Bangladesh in 2005 to that in 2007?
Your response must be concise. 0.79. What is the ratio of the Amount (in $) of Dominica in 2005 to that in 2007?
Offer a terse response. 0.82. What is the ratio of the Amount (in $) of Jamaica in 2005 to that in 2007?
Make the answer very short. 0.75. What is the ratio of the Amount (in $) of Netherlands in 2005 to that in 2007?
Make the answer very short. 0.87. What is the ratio of the Amount (in $) of Bangladesh in 2005 to that in 2008?
Ensure brevity in your answer.  0.64. What is the ratio of the Amount (in $) in Dominica in 2005 to that in 2008?
Give a very brief answer. 0.76. What is the ratio of the Amount (in $) in Jamaica in 2005 to that in 2008?
Your answer should be very brief. 0.68. What is the ratio of the Amount (in $) of Netherlands in 2005 to that in 2008?
Ensure brevity in your answer.  0.81. What is the ratio of the Amount (in $) of Bangladesh in 2005 to that in 2009?
Keep it short and to the point. 0.56. What is the ratio of the Amount (in $) in Dominica in 2005 to that in 2009?
Give a very brief answer. 0.73. What is the ratio of the Amount (in $) of Jamaica in 2005 to that in 2009?
Make the answer very short. 0.62. What is the ratio of the Amount (in $) of Netherlands in 2005 to that in 2009?
Your response must be concise. 0.86. What is the ratio of the Amount (in $) in Bangladesh in 2005 to that in 2010?
Give a very brief answer. 0.49. What is the ratio of the Amount (in $) of Dominica in 2005 to that in 2010?
Provide a succinct answer. 0.72. What is the ratio of the Amount (in $) in Jamaica in 2005 to that in 2010?
Make the answer very short. 0.59. What is the ratio of the Amount (in $) of Netherlands in 2005 to that in 2010?
Provide a short and direct response. 0.83. What is the ratio of the Amount (in $) in Bangladesh in 2005 to that in 2011?
Your answer should be compact. 0.4. What is the ratio of the Amount (in $) in Dominica in 2005 to that in 2011?
Offer a very short reply. 0.71. What is the ratio of the Amount (in $) in Jamaica in 2005 to that in 2011?
Give a very brief answer. 0.57. What is the ratio of the Amount (in $) in Netherlands in 2005 to that in 2011?
Provide a short and direct response. 0.82. What is the ratio of the Amount (in $) in Bangladesh in 2006 to that in 2007?
Your answer should be very brief. 0.87. What is the ratio of the Amount (in $) of Dominica in 2006 to that in 2007?
Give a very brief answer. 0.86. What is the ratio of the Amount (in $) of Jamaica in 2006 to that in 2007?
Offer a very short reply. 0.87. What is the ratio of the Amount (in $) of Bangladesh in 2006 to that in 2008?
Your response must be concise. 0.71. What is the ratio of the Amount (in $) in Dominica in 2006 to that in 2008?
Offer a very short reply. 0.8. What is the ratio of the Amount (in $) of Jamaica in 2006 to that in 2008?
Provide a succinct answer. 0.78. What is the ratio of the Amount (in $) of Netherlands in 2006 to that in 2008?
Keep it short and to the point. 0.89. What is the ratio of the Amount (in $) in Bangladesh in 2006 to that in 2009?
Make the answer very short. 0.62. What is the ratio of the Amount (in $) of Dominica in 2006 to that in 2009?
Keep it short and to the point. 0.77. What is the ratio of the Amount (in $) of Jamaica in 2006 to that in 2009?
Offer a terse response. 0.72. What is the ratio of the Amount (in $) of Netherlands in 2006 to that in 2009?
Provide a succinct answer. 0.95. What is the ratio of the Amount (in $) in Bangladesh in 2006 to that in 2010?
Offer a terse response. 0.54. What is the ratio of the Amount (in $) of Dominica in 2006 to that in 2010?
Provide a short and direct response. 0.76. What is the ratio of the Amount (in $) of Jamaica in 2006 to that in 2010?
Offer a very short reply. 0.69. What is the ratio of the Amount (in $) in Netherlands in 2006 to that in 2010?
Provide a short and direct response. 0.91. What is the ratio of the Amount (in $) of Bangladesh in 2006 to that in 2011?
Your answer should be compact. 0.44. What is the ratio of the Amount (in $) of Dominica in 2006 to that in 2011?
Provide a short and direct response. 0.75. What is the ratio of the Amount (in $) of Jamaica in 2006 to that in 2011?
Offer a very short reply. 0.66. What is the ratio of the Amount (in $) of Netherlands in 2006 to that in 2011?
Your answer should be very brief. 0.91. What is the ratio of the Amount (in $) of Bangladesh in 2007 to that in 2008?
Give a very brief answer. 0.81. What is the ratio of the Amount (in $) of Dominica in 2007 to that in 2008?
Your answer should be compact. 0.92. What is the ratio of the Amount (in $) of Jamaica in 2007 to that in 2008?
Provide a succinct answer. 0.9. What is the ratio of the Amount (in $) in Netherlands in 2007 to that in 2008?
Give a very brief answer. 0.93. What is the ratio of the Amount (in $) in Bangladesh in 2007 to that in 2009?
Give a very brief answer. 0.71. What is the ratio of the Amount (in $) in Dominica in 2007 to that in 2009?
Provide a short and direct response. 0.89. What is the ratio of the Amount (in $) of Jamaica in 2007 to that in 2009?
Your response must be concise. 0.83. What is the ratio of the Amount (in $) in Netherlands in 2007 to that in 2009?
Offer a terse response. 0.99. What is the ratio of the Amount (in $) of Bangladesh in 2007 to that in 2010?
Provide a short and direct response. 0.62. What is the ratio of the Amount (in $) in Dominica in 2007 to that in 2010?
Ensure brevity in your answer.  0.89. What is the ratio of the Amount (in $) in Jamaica in 2007 to that in 2010?
Provide a succinct answer. 0.79. What is the ratio of the Amount (in $) of Netherlands in 2007 to that in 2010?
Ensure brevity in your answer.  0.95. What is the ratio of the Amount (in $) of Bangladesh in 2007 to that in 2011?
Keep it short and to the point. 0.51. What is the ratio of the Amount (in $) of Dominica in 2007 to that in 2011?
Your answer should be compact. 0.87. What is the ratio of the Amount (in $) in Jamaica in 2007 to that in 2011?
Keep it short and to the point. 0.76. What is the ratio of the Amount (in $) in Netherlands in 2007 to that in 2011?
Your answer should be very brief. 0.95. What is the ratio of the Amount (in $) of Bangladesh in 2008 to that in 2009?
Offer a terse response. 0.88. What is the ratio of the Amount (in $) in Dominica in 2008 to that in 2009?
Your response must be concise. 0.96. What is the ratio of the Amount (in $) in Jamaica in 2008 to that in 2009?
Ensure brevity in your answer.  0.91. What is the ratio of the Amount (in $) in Netherlands in 2008 to that in 2009?
Keep it short and to the point. 1.06. What is the ratio of the Amount (in $) in Bangladesh in 2008 to that in 2010?
Keep it short and to the point. 0.77. What is the ratio of the Amount (in $) of Dominica in 2008 to that in 2010?
Your answer should be very brief. 0.96. What is the ratio of the Amount (in $) in Jamaica in 2008 to that in 2010?
Your response must be concise. 0.88. What is the ratio of the Amount (in $) in Netherlands in 2008 to that in 2010?
Offer a very short reply. 1.03. What is the ratio of the Amount (in $) of Bangladesh in 2008 to that in 2011?
Provide a succinct answer. 0.62. What is the ratio of the Amount (in $) in Dominica in 2008 to that in 2011?
Ensure brevity in your answer.  0.95. What is the ratio of the Amount (in $) in Jamaica in 2008 to that in 2011?
Offer a very short reply. 0.84. What is the ratio of the Amount (in $) of Netherlands in 2008 to that in 2011?
Keep it short and to the point. 1.02. What is the ratio of the Amount (in $) of Bangladesh in 2009 to that in 2010?
Offer a terse response. 0.87. What is the ratio of the Amount (in $) of Jamaica in 2009 to that in 2010?
Offer a terse response. 0.96. What is the ratio of the Amount (in $) in Netherlands in 2009 to that in 2010?
Give a very brief answer. 0.96. What is the ratio of the Amount (in $) in Bangladesh in 2009 to that in 2011?
Your response must be concise. 0.71. What is the ratio of the Amount (in $) in Dominica in 2009 to that in 2011?
Your response must be concise. 0.98. What is the ratio of the Amount (in $) in Jamaica in 2009 to that in 2011?
Provide a succinct answer. 0.92. What is the ratio of the Amount (in $) of Netherlands in 2009 to that in 2011?
Your response must be concise. 0.96. What is the ratio of the Amount (in $) of Bangladesh in 2010 to that in 2011?
Give a very brief answer. 0.81. What is the ratio of the Amount (in $) in Dominica in 2010 to that in 2011?
Give a very brief answer. 0.98. What is the ratio of the Amount (in $) of Netherlands in 2010 to that in 2011?
Provide a succinct answer. 0.99. What is the difference between the highest and the second highest Amount (in $) of Bangladesh?
Provide a short and direct response. 1.81e+11. What is the difference between the highest and the second highest Amount (in $) in Dominica?
Provide a succinct answer. 5.50e+06. What is the difference between the highest and the second highest Amount (in $) of Jamaica?
Provide a short and direct response. 1.55e+1. What is the difference between the highest and the second highest Amount (in $) in Netherlands?
Provide a short and direct response. 4.76e+09. What is the difference between the highest and the lowest Amount (in $) of Bangladesh?
Offer a very short reply. 6.26e+11. What is the difference between the highest and the lowest Amount (in $) in Dominica?
Provide a succinct answer. 1.23e+08. What is the difference between the highest and the lowest Amount (in $) of Jamaica?
Provide a short and direct response. 1.82e+11. What is the difference between the highest and the lowest Amount (in $) of Netherlands?
Offer a very short reply. 5.79e+1. 